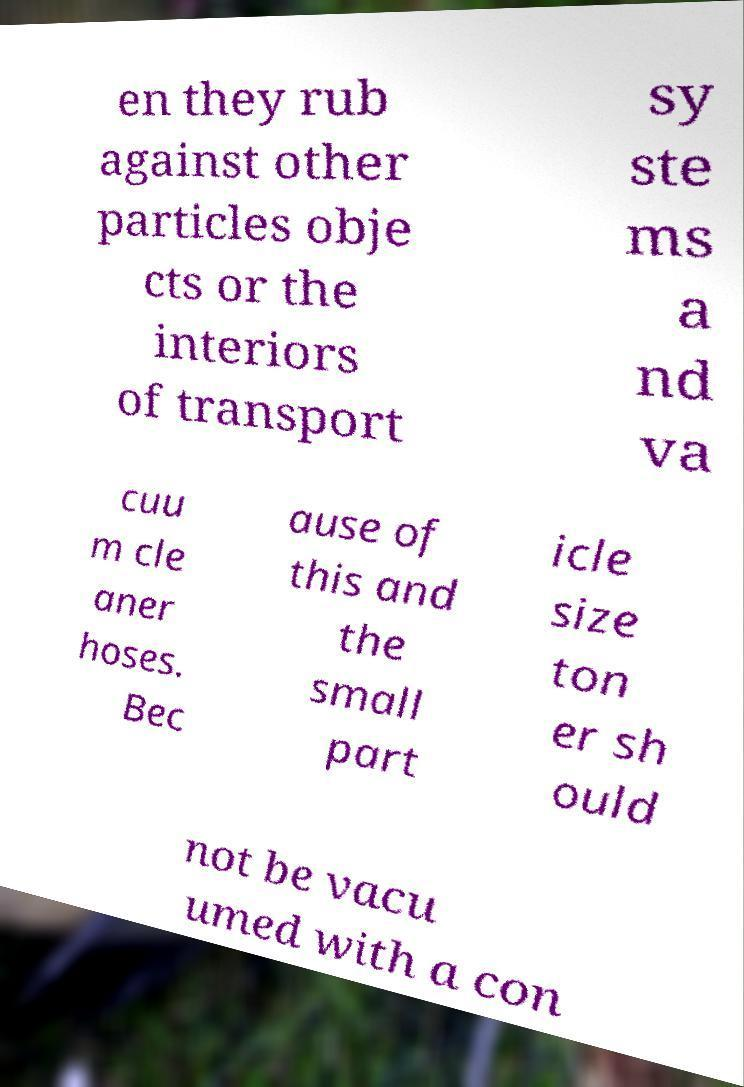Could you assist in decoding the text presented in this image and type it out clearly? en they rub against other particles obje cts or the interiors of transport sy ste ms a nd va cuu m cle aner hoses. Bec ause of this and the small part icle size ton er sh ould not be vacu umed with a con 